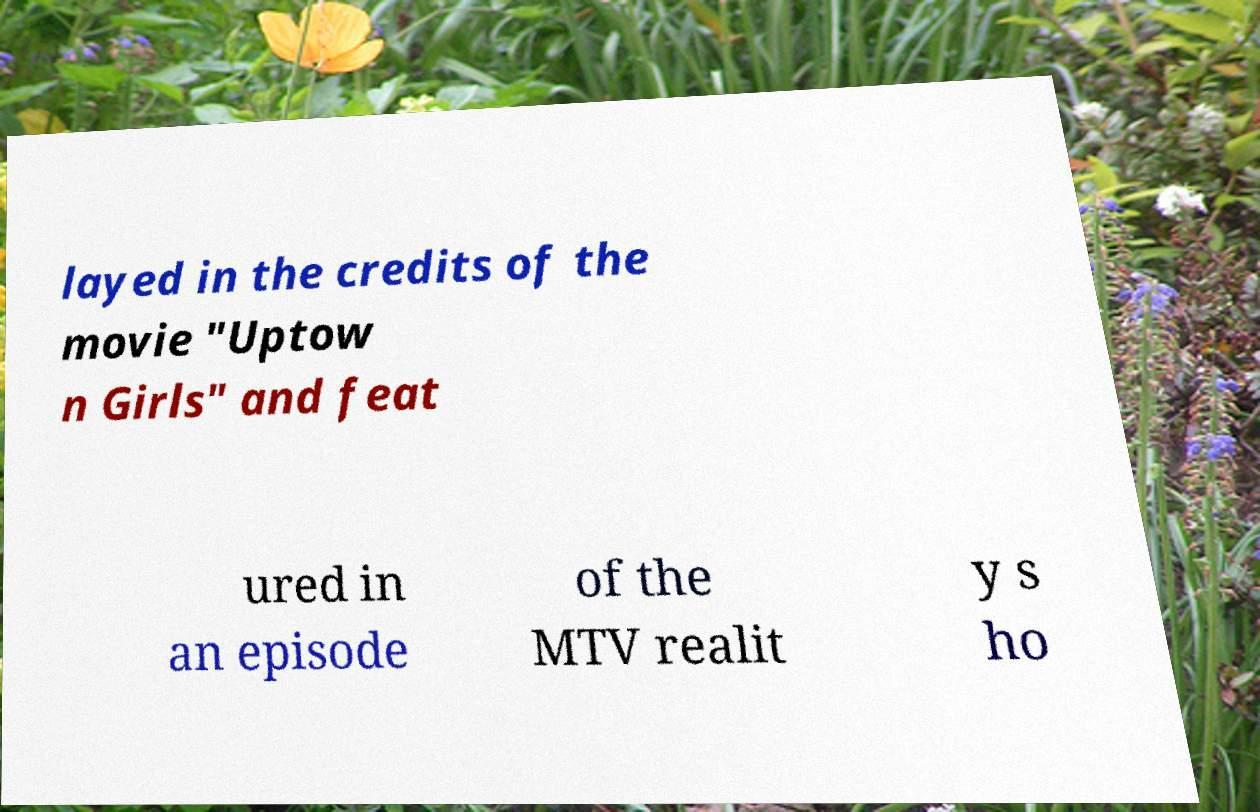Could you extract and type out the text from this image? layed in the credits of the movie "Uptow n Girls" and feat ured in an episode of the MTV realit y s ho 